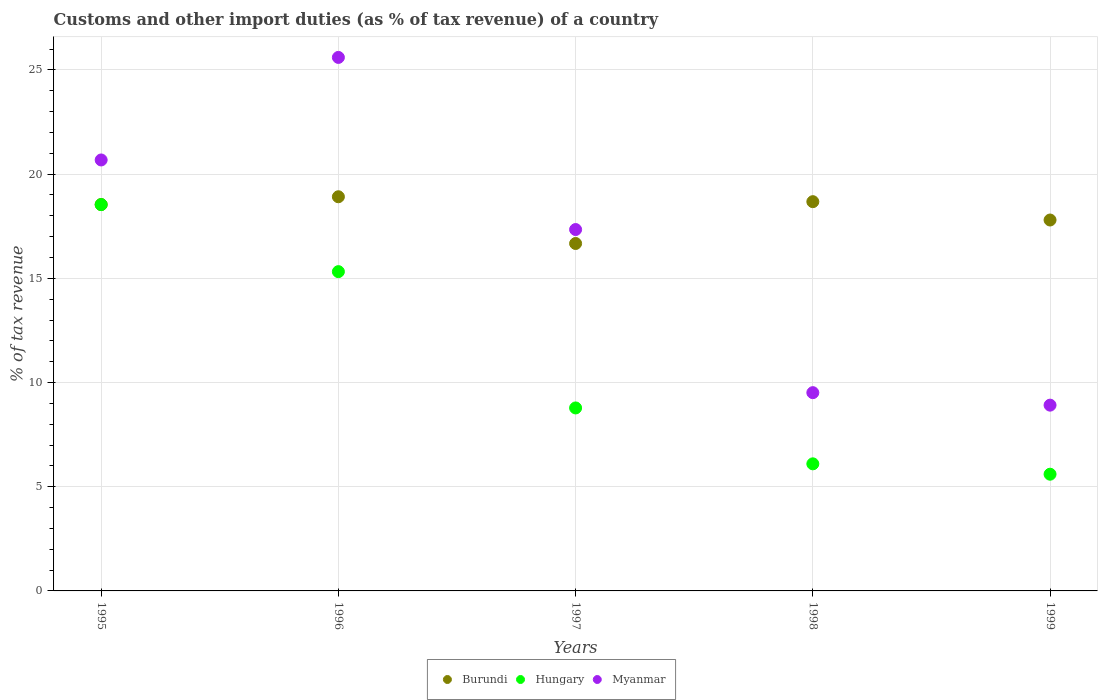How many different coloured dotlines are there?
Offer a terse response. 3. Is the number of dotlines equal to the number of legend labels?
Your response must be concise. Yes. What is the percentage of tax revenue from customs in Hungary in 1999?
Your answer should be very brief. 5.6. Across all years, what is the maximum percentage of tax revenue from customs in Hungary?
Ensure brevity in your answer.  18.54. Across all years, what is the minimum percentage of tax revenue from customs in Burundi?
Offer a very short reply. 16.67. What is the total percentage of tax revenue from customs in Hungary in the graph?
Your answer should be very brief. 54.34. What is the difference between the percentage of tax revenue from customs in Myanmar in 1995 and that in 1997?
Your answer should be very brief. 3.34. What is the difference between the percentage of tax revenue from customs in Hungary in 1999 and the percentage of tax revenue from customs in Myanmar in 1996?
Give a very brief answer. -20. What is the average percentage of tax revenue from customs in Burundi per year?
Keep it short and to the point. 18.12. In the year 1995, what is the difference between the percentage of tax revenue from customs in Myanmar and percentage of tax revenue from customs in Hungary?
Your answer should be very brief. 2.14. In how many years, is the percentage of tax revenue from customs in Myanmar greater than 14 %?
Ensure brevity in your answer.  3. What is the ratio of the percentage of tax revenue from customs in Myanmar in 1998 to that in 1999?
Make the answer very short. 1.07. Is the difference between the percentage of tax revenue from customs in Myanmar in 1996 and 1998 greater than the difference between the percentage of tax revenue from customs in Hungary in 1996 and 1998?
Keep it short and to the point. Yes. What is the difference between the highest and the second highest percentage of tax revenue from customs in Burundi?
Offer a very short reply. 0.24. What is the difference between the highest and the lowest percentage of tax revenue from customs in Burundi?
Your response must be concise. 2.24. Is the sum of the percentage of tax revenue from customs in Hungary in 1996 and 1999 greater than the maximum percentage of tax revenue from customs in Burundi across all years?
Provide a short and direct response. Yes. Is the percentage of tax revenue from customs in Hungary strictly less than the percentage of tax revenue from customs in Myanmar over the years?
Your response must be concise. Yes. How many dotlines are there?
Provide a succinct answer. 3. How many years are there in the graph?
Give a very brief answer. 5. What is the difference between two consecutive major ticks on the Y-axis?
Offer a very short reply. 5. Are the values on the major ticks of Y-axis written in scientific E-notation?
Your answer should be compact. No. Does the graph contain grids?
Make the answer very short. Yes. Where does the legend appear in the graph?
Provide a short and direct response. Bottom center. How many legend labels are there?
Offer a very short reply. 3. How are the legend labels stacked?
Your answer should be very brief. Horizontal. What is the title of the graph?
Provide a succinct answer. Customs and other import duties (as % of tax revenue) of a country. What is the label or title of the Y-axis?
Ensure brevity in your answer.  % of tax revenue. What is the % of tax revenue of Burundi in 1995?
Make the answer very short. 18.54. What is the % of tax revenue of Hungary in 1995?
Make the answer very short. 18.54. What is the % of tax revenue of Myanmar in 1995?
Provide a succinct answer. 20.68. What is the % of tax revenue in Burundi in 1996?
Your answer should be compact. 18.92. What is the % of tax revenue in Hungary in 1996?
Offer a very short reply. 15.32. What is the % of tax revenue in Myanmar in 1996?
Make the answer very short. 25.6. What is the % of tax revenue in Burundi in 1997?
Provide a short and direct response. 16.67. What is the % of tax revenue in Hungary in 1997?
Your response must be concise. 8.78. What is the % of tax revenue of Myanmar in 1997?
Keep it short and to the point. 17.34. What is the % of tax revenue of Burundi in 1998?
Make the answer very short. 18.68. What is the % of tax revenue in Hungary in 1998?
Your answer should be compact. 6.1. What is the % of tax revenue in Myanmar in 1998?
Offer a terse response. 9.51. What is the % of tax revenue of Burundi in 1999?
Provide a succinct answer. 17.8. What is the % of tax revenue of Hungary in 1999?
Keep it short and to the point. 5.6. What is the % of tax revenue of Myanmar in 1999?
Ensure brevity in your answer.  8.91. Across all years, what is the maximum % of tax revenue of Burundi?
Your answer should be compact. 18.92. Across all years, what is the maximum % of tax revenue of Hungary?
Offer a very short reply. 18.54. Across all years, what is the maximum % of tax revenue in Myanmar?
Make the answer very short. 25.6. Across all years, what is the minimum % of tax revenue in Burundi?
Ensure brevity in your answer.  16.67. Across all years, what is the minimum % of tax revenue of Hungary?
Your answer should be compact. 5.6. Across all years, what is the minimum % of tax revenue in Myanmar?
Make the answer very short. 8.91. What is the total % of tax revenue in Burundi in the graph?
Offer a very short reply. 90.61. What is the total % of tax revenue of Hungary in the graph?
Your answer should be compact. 54.34. What is the total % of tax revenue in Myanmar in the graph?
Provide a short and direct response. 82.05. What is the difference between the % of tax revenue in Burundi in 1995 and that in 1996?
Ensure brevity in your answer.  -0.37. What is the difference between the % of tax revenue of Hungary in 1995 and that in 1996?
Your response must be concise. 3.22. What is the difference between the % of tax revenue in Myanmar in 1995 and that in 1996?
Keep it short and to the point. -4.92. What is the difference between the % of tax revenue in Burundi in 1995 and that in 1997?
Your response must be concise. 1.87. What is the difference between the % of tax revenue in Hungary in 1995 and that in 1997?
Make the answer very short. 9.76. What is the difference between the % of tax revenue of Myanmar in 1995 and that in 1997?
Offer a very short reply. 3.34. What is the difference between the % of tax revenue in Burundi in 1995 and that in 1998?
Make the answer very short. -0.14. What is the difference between the % of tax revenue of Hungary in 1995 and that in 1998?
Your answer should be compact. 12.44. What is the difference between the % of tax revenue in Myanmar in 1995 and that in 1998?
Provide a succinct answer. 11.17. What is the difference between the % of tax revenue of Burundi in 1995 and that in 1999?
Provide a succinct answer. 0.74. What is the difference between the % of tax revenue in Hungary in 1995 and that in 1999?
Offer a terse response. 12.94. What is the difference between the % of tax revenue in Myanmar in 1995 and that in 1999?
Provide a short and direct response. 11.77. What is the difference between the % of tax revenue in Burundi in 1996 and that in 1997?
Offer a terse response. 2.24. What is the difference between the % of tax revenue in Hungary in 1996 and that in 1997?
Your answer should be compact. 6.54. What is the difference between the % of tax revenue in Myanmar in 1996 and that in 1997?
Offer a terse response. 8.26. What is the difference between the % of tax revenue of Burundi in 1996 and that in 1998?
Your answer should be compact. 0.24. What is the difference between the % of tax revenue in Hungary in 1996 and that in 1998?
Offer a very short reply. 9.22. What is the difference between the % of tax revenue of Myanmar in 1996 and that in 1998?
Offer a terse response. 16.09. What is the difference between the % of tax revenue in Burundi in 1996 and that in 1999?
Give a very brief answer. 1.12. What is the difference between the % of tax revenue in Hungary in 1996 and that in 1999?
Keep it short and to the point. 9.72. What is the difference between the % of tax revenue of Myanmar in 1996 and that in 1999?
Provide a short and direct response. 16.69. What is the difference between the % of tax revenue of Burundi in 1997 and that in 1998?
Offer a very short reply. -2.01. What is the difference between the % of tax revenue of Hungary in 1997 and that in 1998?
Your response must be concise. 2.68. What is the difference between the % of tax revenue of Myanmar in 1997 and that in 1998?
Offer a terse response. 7.83. What is the difference between the % of tax revenue of Burundi in 1997 and that in 1999?
Provide a succinct answer. -1.13. What is the difference between the % of tax revenue in Hungary in 1997 and that in 1999?
Keep it short and to the point. 3.18. What is the difference between the % of tax revenue in Myanmar in 1997 and that in 1999?
Give a very brief answer. 8.43. What is the difference between the % of tax revenue in Burundi in 1998 and that in 1999?
Ensure brevity in your answer.  0.88. What is the difference between the % of tax revenue in Hungary in 1998 and that in 1999?
Ensure brevity in your answer.  0.5. What is the difference between the % of tax revenue of Myanmar in 1998 and that in 1999?
Your response must be concise. 0.6. What is the difference between the % of tax revenue in Burundi in 1995 and the % of tax revenue in Hungary in 1996?
Keep it short and to the point. 3.22. What is the difference between the % of tax revenue in Burundi in 1995 and the % of tax revenue in Myanmar in 1996?
Offer a very short reply. -7.06. What is the difference between the % of tax revenue of Hungary in 1995 and the % of tax revenue of Myanmar in 1996?
Your answer should be compact. -7.06. What is the difference between the % of tax revenue of Burundi in 1995 and the % of tax revenue of Hungary in 1997?
Make the answer very short. 9.76. What is the difference between the % of tax revenue in Burundi in 1995 and the % of tax revenue in Myanmar in 1997?
Ensure brevity in your answer.  1.2. What is the difference between the % of tax revenue of Hungary in 1995 and the % of tax revenue of Myanmar in 1997?
Your answer should be very brief. 1.2. What is the difference between the % of tax revenue in Burundi in 1995 and the % of tax revenue in Hungary in 1998?
Make the answer very short. 12.44. What is the difference between the % of tax revenue in Burundi in 1995 and the % of tax revenue in Myanmar in 1998?
Make the answer very short. 9.03. What is the difference between the % of tax revenue in Hungary in 1995 and the % of tax revenue in Myanmar in 1998?
Offer a very short reply. 9.02. What is the difference between the % of tax revenue of Burundi in 1995 and the % of tax revenue of Hungary in 1999?
Make the answer very short. 12.94. What is the difference between the % of tax revenue of Burundi in 1995 and the % of tax revenue of Myanmar in 1999?
Provide a short and direct response. 9.63. What is the difference between the % of tax revenue in Hungary in 1995 and the % of tax revenue in Myanmar in 1999?
Your response must be concise. 9.62. What is the difference between the % of tax revenue in Burundi in 1996 and the % of tax revenue in Hungary in 1997?
Ensure brevity in your answer.  10.13. What is the difference between the % of tax revenue of Burundi in 1996 and the % of tax revenue of Myanmar in 1997?
Make the answer very short. 1.57. What is the difference between the % of tax revenue of Hungary in 1996 and the % of tax revenue of Myanmar in 1997?
Ensure brevity in your answer.  -2.02. What is the difference between the % of tax revenue in Burundi in 1996 and the % of tax revenue in Hungary in 1998?
Make the answer very short. 12.82. What is the difference between the % of tax revenue of Burundi in 1996 and the % of tax revenue of Myanmar in 1998?
Provide a succinct answer. 9.4. What is the difference between the % of tax revenue of Hungary in 1996 and the % of tax revenue of Myanmar in 1998?
Provide a short and direct response. 5.81. What is the difference between the % of tax revenue in Burundi in 1996 and the % of tax revenue in Hungary in 1999?
Make the answer very short. 13.31. What is the difference between the % of tax revenue of Burundi in 1996 and the % of tax revenue of Myanmar in 1999?
Ensure brevity in your answer.  10. What is the difference between the % of tax revenue of Hungary in 1996 and the % of tax revenue of Myanmar in 1999?
Ensure brevity in your answer.  6.41. What is the difference between the % of tax revenue of Burundi in 1997 and the % of tax revenue of Hungary in 1998?
Your answer should be compact. 10.57. What is the difference between the % of tax revenue of Burundi in 1997 and the % of tax revenue of Myanmar in 1998?
Make the answer very short. 7.16. What is the difference between the % of tax revenue of Hungary in 1997 and the % of tax revenue of Myanmar in 1998?
Your answer should be very brief. -0.73. What is the difference between the % of tax revenue of Burundi in 1997 and the % of tax revenue of Hungary in 1999?
Your answer should be very brief. 11.07. What is the difference between the % of tax revenue of Burundi in 1997 and the % of tax revenue of Myanmar in 1999?
Provide a succinct answer. 7.76. What is the difference between the % of tax revenue in Hungary in 1997 and the % of tax revenue in Myanmar in 1999?
Keep it short and to the point. -0.13. What is the difference between the % of tax revenue of Burundi in 1998 and the % of tax revenue of Hungary in 1999?
Offer a very short reply. 13.08. What is the difference between the % of tax revenue in Burundi in 1998 and the % of tax revenue in Myanmar in 1999?
Your answer should be compact. 9.76. What is the difference between the % of tax revenue of Hungary in 1998 and the % of tax revenue of Myanmar in 1999?
Your answer should be very brief. -2.82. What is the average % of tax revenue in Burundi per year?
Your response must be concise. 18.12. What is the average % of tax revenue in Hungary per year?
Provide a short and direct response. 10.87. What is the average % of tax revenue of Myanmar per year?
Give a very brief answer. 16.41. In the year 1995, what is the difference between the % of tax revenue in Burundi and % of tax revenue in Hungary?
Your answer should be very brief. 0. In the year 1995, what is the difference between the % of tax revenue of Burundi and % of tax revenue of Myanmar?
Make the answer very short. -2.14. In the year 1995, what is the difference between the % of tax revenue in Hungary and % of tax revenue in Myanmar?
Keep it short and to the point. -2.14. In the year 1996, what is the difference between the % of tax revenue of Burundi and % of tax revenue of Hungary?
Provide a short and direct response. 3.59. In the year 1996, what is the difference between the % of tax revenue in Burundi and % of tax revenue in Myanmar?
Offer a very short reply. -6.69. In the year 1996, what is the difference between the % of tax revenue in Hungary and % of tax revenue in Myanmar?
Your response must be concise. -10.28. In the year 1997, what is the difference between the % of tax revenue in Burundi and % of tax revenue in Hungary?
Provide a short and direct response. 7.89. In the year 1997, what is the difference between the % of tax revenue of Burundi and % of tax revenue of Myanmar?
Your answer should be compact. -0.67. In the year 1997, what is the difference between the % of tax revenue of Hungary and % of tax revenue of Myanmar?
Give a very brief answer. -8.56. In the year 1998, what is the difference between the % of tax revenue of Burundi and % of tax revenue of Hungary?
Your response must be concise. 12.58. In the year 1998, what is the difference between the % of tax revenue of Burundi and % of tax revenue of Myanmar?
Keep it short and to the point. 9.17. In the year 1998, what is the difference between the % of tax revenue of Hungary and % of tax revenue of Myanmar?
Offer a terse response. -3.42. In the year 1999, what is the difference between the % of tax revenue of Burundi and % of tax revenue of Hungary?
Provide a short and direct response. 12.2. In the year 1999, what is the difference between the % of tax revenue in Burundi and % of tax revenue in Myanmar?
Provide a short and direct response. 8.88. In the year 1999, what is the difference between the % of tax revenue in Hungary and % of tax revenue in Myanmar?
Offer a very short reply. -3.31. What is the ratio of the % of tax revenue in Burundi in 1995 to that in 1996?
Give a very brief answer. 0.98. What is the ratio of the % of tax revenue of Hungary in 1995 to that in 1996?
Provide a succinct answer. 1.21. What is the ratio of the % of tax revenue in Myanmar in 1995 to that in 1996?
Provide a succinct answer. 0.81. What is the ratio of the % of tax revenue of Burundi in 1995 to that in 1997?
Your answer should be very brief. 1.11. What is the ratio of the % of tax revenue in Hungary in 1995 to that in 1997?
Provide a succinct answer. 2.11. What is the ratio of the % of tax revenue in Myanmar in 1995 to that in 1997?
Ensure brevity in your answer.  1.19. What is the ratio of the % of tax revenue in Burundi in 1995 to that in 1998?
Your answer should be compact. 0.99. What is the ratio of the % of tax revenue in Hungary in 1995 to that in 1998?
Your answer should be very brief. 3.04. What is the ratio of the % of tax revenue in Myanmar in 1995 to that in 1998?
Provide a short and direct response. 2.17. What is the ratio of the % of tax revenue in Burundi in 1995 to that in 1999?
Provide a short and direct response. 1.04. What is the ratio of the % of tax revenue of Hungary in 1995 to that in 1999?
Your answer should be very brief. 3.31. What is the ratio of the % of tax revenue in Myanmar in 1995 to that in 1999?
Provide a short and direct response. 2.32. What is the ratio of the % of tax revenue of Burundi in 1996 to that in 1997?
Make the answer very short. 1.13. What is the ratio of the % of tax revenue of Hungary in 1996 to that in 1997?
Offer a very short reply. 1.74. What is the ratio of the % of tax revenue in Myanmar in 1996 to that in 1997?
Provide a short and direct response. 1.48. What is the ratio of the % of tax revenue in Burundi in 1996 to that in 1998?
Offer a terse response. 1.01. What is the ratio of the % of tax revenue of Hungary in 1996 to that in 1998?
Your answer should be very brief. 2.51. What is the ratio of the % of tax revenue of Myanmar in 1996 to that in 1998?
Keep it short and to the point. 2.69. What is the ratio of the % of tax revenue in Burundi in 1996 to that in 1999?
Give a very brief answer. 1.06. What is the ratio of the % of tax revenue in Hungary in 1996 to that in 1999?
Your answer should be compact. 2.74. What is the ratio of the % of tax revenue in Myanmar in 1996 to that in 1999?
Provide a succinct answer. 2.87. What is the ratio of the % of tax revenue of Burundi in 1997 to that in 1998?
Your response must be concise. 0.89. What is the ratio of the % of tax revenue in Hungary in 1997 to that in 1998?
Offer a very short reply. 1.44. What is the ratio of the % of tax revenue of Myanmar in 1997 to that in 1998?
Give a very brief answer. 1.82. What is the ratio of the % of tax revenue in Burundi in 1997 to that in 1999?
Ensure brevity in your answer.  0.94. What is the ratio of the % of tax revenue in Hungary in 1997 to that in 1999?
Your answer should be compact. 1.57. What is the ratio of the % of tax revenue of Myanmar in 1997 to that in 1999?
Keep it short and to the point. 1.95. What is the ratio of the % of tax revenue of Burundi in 1998 to that in 1999?
Your answer should be very brief. 1.05. What is the ratio of the % of tax revenue of Hungary in 1998 to that in 1999?
Your answer should be very brief. 1.09. What is the ratio of the % of tax revenue of Myanmar in 1998 to that in 1999?
Offer a very short reply. 1.07. What is the difference between the highest and the second highest % of tax revenue of Burundi?
Keep it short and to the point. 0.24. What is the difference between the highest and the second highest % of tax revenue in Hungary?
Provide a succinct answer. 3.22. What is the difference between the highest and the second highest % of tax revenue of Myanmar?
Keep it short and to the point. 4.92. What is the difference between the highest and the lowest % of tax revenue of Burundi?
Give a very brief answer. 2.24. What is the difference between the highest and the lowest % of tax revenue in Hungary?
Make the answer very short. 12.94. What is the difference between the highest and the lowest % of tax revenue of Myanmar?
Offer a terse response. 16.69. 